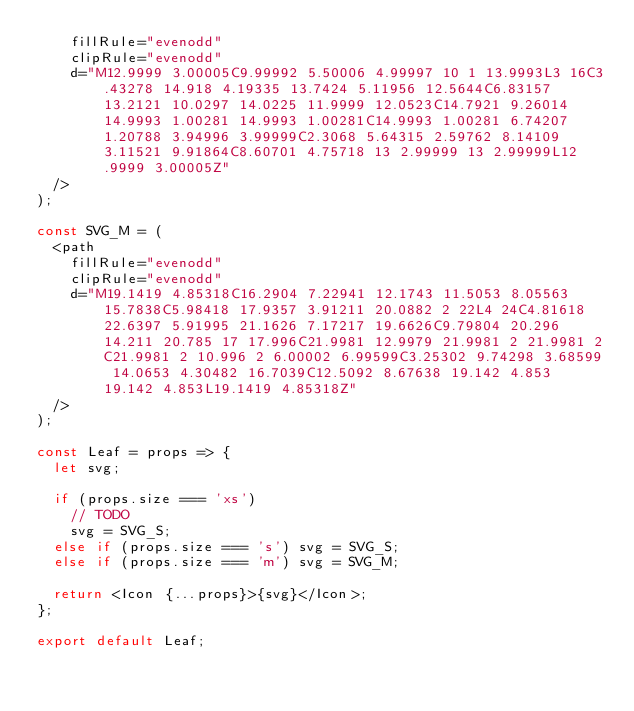<code> <loc_0><loc_0><loc_500><loc_500><_TypeScript_>    fillRule="evenodd"
    clipRule="evenodd"
    d="M12.9999 3.00005C9.99992 5.50006 4.99997 10 1 13.9993L3 16C3.43278 14.918 4.19335 13.7424 5.11956 12.5644C6.83157 13.2121 10.0297 14.0225 11.9999 12.0523C14.7921 9.26014 14.9993 1.00281 14.9993 1.00281C14.9993 1.00281 6.74207 1.20788 3.94996 3.99999C2.3068 5.64315 2.59762 8.14109 3.11521 9.91864C8.60701 4.75718 13 2.99999 13 2.99999L12.9999 3.00005Z"
  />
);

const SVG_M = (
  <path
    fillRule="evenodd"
    clipRule="evenodd"
    d="M19.1419 4.85318C16.2904 7.22941 12.1743 11.5053 8.05563 15.7838C5.98418 17.9357 3.91211 20.0882 2 22L4 24C4.81618 22.6397 5.91995 21.1626 7.17217 19.6626C9.79804 20.296 14.211 20.785 17 17.996C21.9981 12.9979 21.9981 2 21.9981 2C21.9981 2 10.996 2 6.00002 6.99599C3.25302 9.74298 3.68599 14.0653 4.30482 16.7039C12.5092 8.67638 19.142 4.853 19.142 4.853L19.1419 4.85318Z"
  />
);

const Leaf = props => {
  let svg;

  if (props.size === 'xs')
    // TODO
    svg = SVG_S;
  else if (props.size === 's') svg = SVG_S;
  else if (props.size === 'm') svg = SVG_M;

  return <Icon {...props}>{svg}</Icon>;
};

export default Leaf;
</code> 